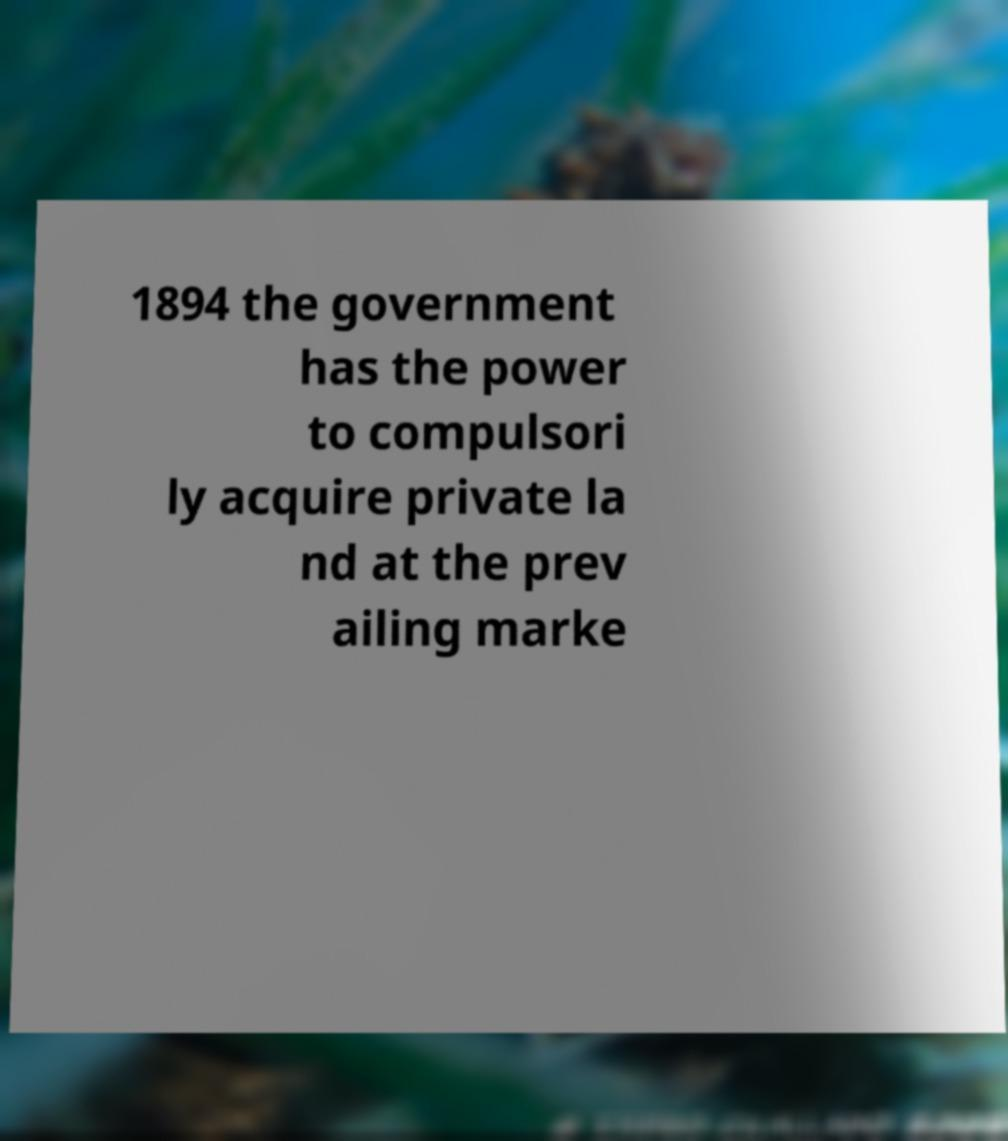Please read and relay the text visible in this image. What does it say? 1894 the government has the power to compulsori ly acquire private la nd at the prev ailing marke 